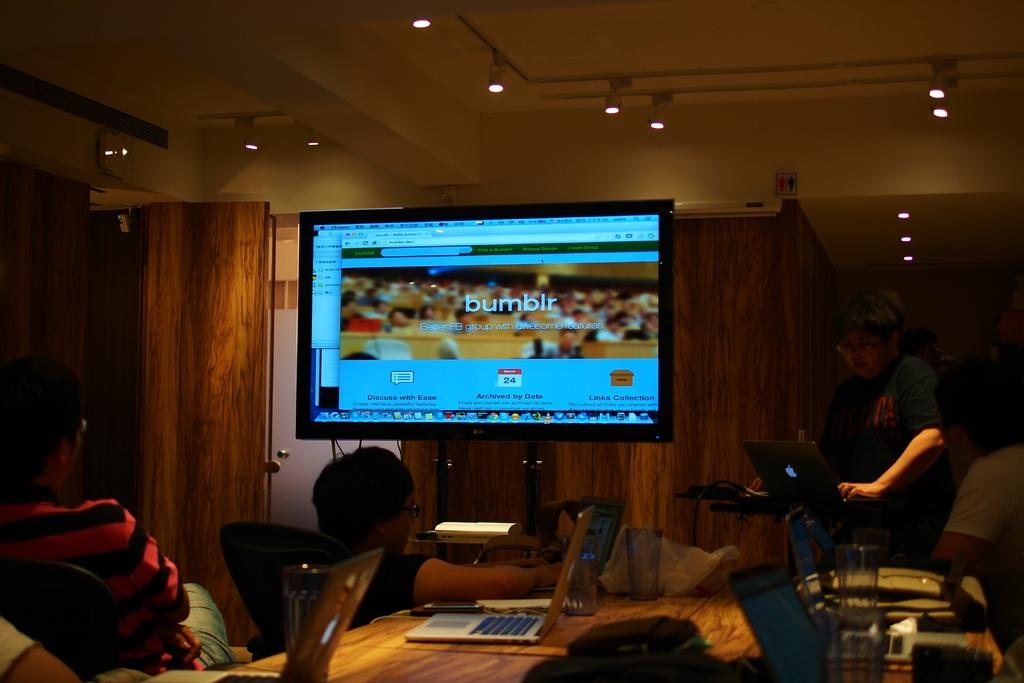<image>
Give a short and clear explanation of the subsequent image. A giant computer monitor is open to a webpage for bumblr. 